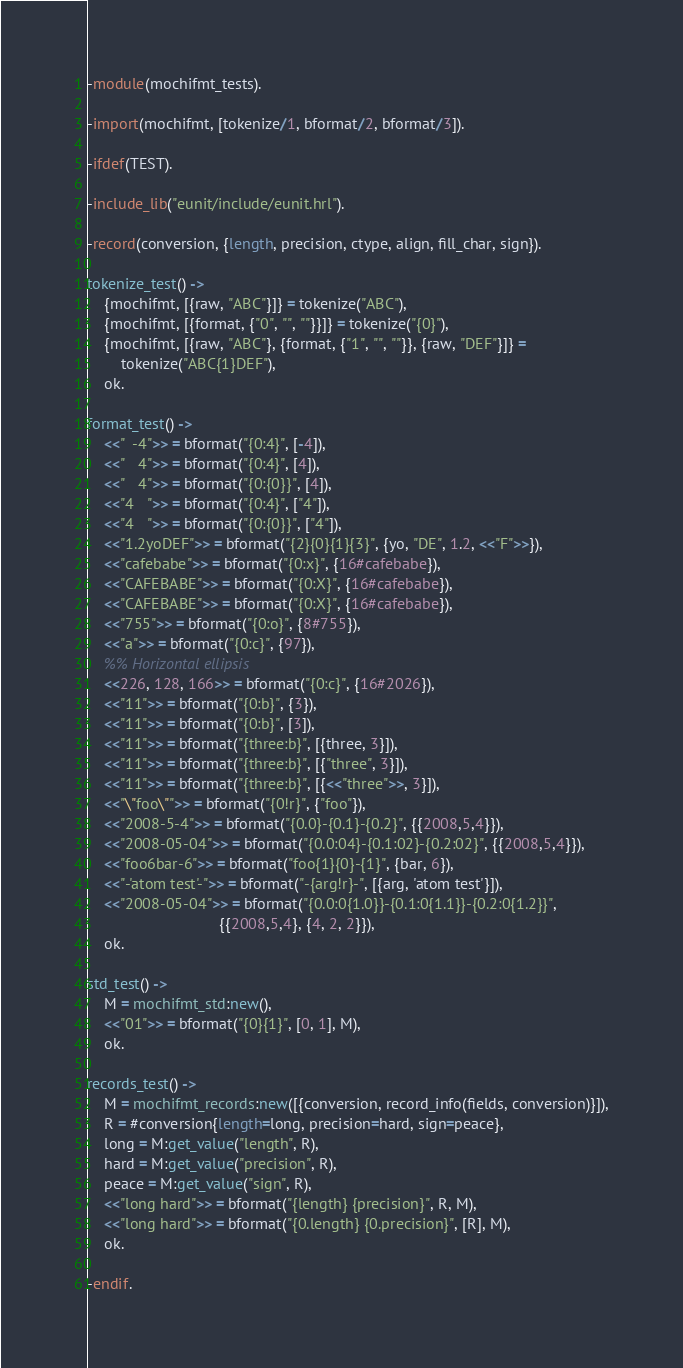Convert code to text. <code><loc_0><loc_0><loc_500><loc_500><_Erlang_>
-module(mochifmt_tests).

-import(mochifmt, [tokenize/1, bformat/2, bformat/3]).

-ifdef(TEST).

-include_lib("eunit/include/eunit.hrl").

-record(conversion, {length, precision, ctype, align, fill_char, sign}).

tokenize_test() ->
    {mochifmt, [{raw, "ABC"}]} = tokenize("ABC"),
    {mochifmt, [{format, {"0", "", ""}}]} = tokenize("{0}"),
    {mochifmt, [{raw, "ABC"}, {format, {"1", "", ""}}, {raw, "DEF"}]} =
        tokenize("ABC{1}DEF"),
    ok.

format_test() ->
    <<"  -4">> = bformat("{0:4}", [-4]),
    <<"   4">> = bformat("{0:4}", [4]),
    <<"   4">> = bformat("{0:{0}}", [4]),
    <<"4   ">> = bformat("{0:4}", ["4"]),
    <<"4   ">> = bformat("{0:{0}}", ["4"]),
    <<"1.2yoDEF">> = bformat("{2}{0}{1}{3}", {yo, "DE", 1.2, <<"F">>}),
    <<"cafebabe">> = bformat("{0:x}", {16#cafebabe}),
    <<"CAFEBABE">> = bformat("{0:X}", {16#cafebabe}),
    <<"CAFEBABE">> = bformat("{0:X}", {16#cafebabe}),
    <<"755">> = bformat("{0:o}", {8#755}),
    <<"a">> = bformat("{0:c}", {97}),
    %% Horizontal ellipsis
    <<226, 128, 166>> = bformat("{0:c}", {16#2026}),
    <<"11">> = bformat("{0:b}", {3}),
    <<"11">> = bformat("{0:b}", [3]),
    <<"11">> = bformat("{three:b}", [{three, 3}]),
    <<"11">> = bformat("{three:b}", [{"three", 3}]),
    <<"11">> = bformat("{three:b}", [{<<"three">>, 3}]),
    <<"\"foo\"">> = bformat("{0!r}", {"foo"}),
    <<"2008-5-4">> = bformat("{0.0}-{0.1}-{0.2}", {{2008,5,4}}),
    <<"2008-05-04">> = bformat("{0.0:04}-{0.1:02}-{0.2:02}", {{2008,5,4}}),
    <<"foo6bar-6">> = bformat("foo{1}{0}-{1}", {bar, 6}),
    <<"-'atom test'-">> = bformat("-{arg!r}-", [{arg, 'atom test'}]),
    <<"2008-05-04">> = bformat("{0.0:0{1.0}}-{0.1:0{1.1}}-{0.2:0{1.2}}",
                               {{2008,5,4}, {4, 2, 2}}),
    ok.

std_test() ->
    M = mochifmt_std:new(),
    <<"01">> = bformat("{0}{1}", [0, 1], M),
    ok.

records_test() ->
    M = mochifmt_records:new([{conversion, record_info(fields, conversion)}]),
    R = #conversion{length=long, precision=hard, sign=peace},
    long = M:get_value("length", R),
    hard = M:get_value("precision", R),
    peace = M:get_value("sign", R),
    <<"long hard">> = bformat("{length} {precision}", R, M),
    <<"long hard">> = bformat("{0.length} {0.precision}", [R], M),
    ok.

-endif.

</code> 